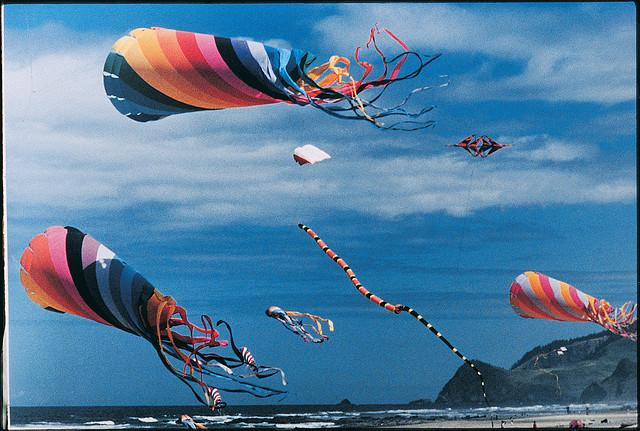What do the kites resemble? Please explain your reasoning. squid. They have oblong bodies with many narrow, long tails on each one. 